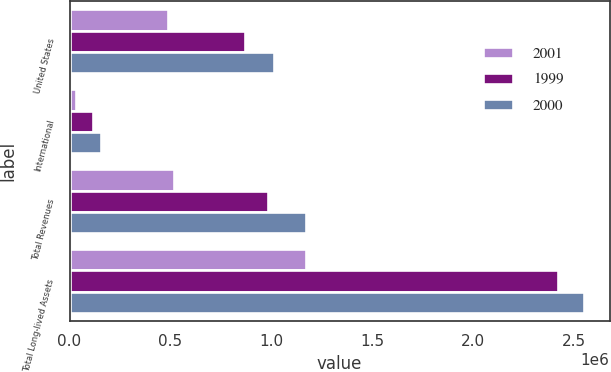<chart> <loc_0><loc_0><loc_500><loc_500><stacked_bar_chart><ecel><fcel>United States<fcel>International<fcel>Total Revenues<fcel>Total Long-lived Assets<nl><fcel>2001<fcel>487931<fcel>31618<fcel>519549<fcel>1.17355e+06<nl><fcel>1999<fcel>869684<fcel>116687<fcel>986371<fcel>2.42243e+06<nl><fcel>2000<fcel>1.01362e+06<fcel>157499<fcel>1.17112e+06<fcel>2.55059e+06<nl></chart> 